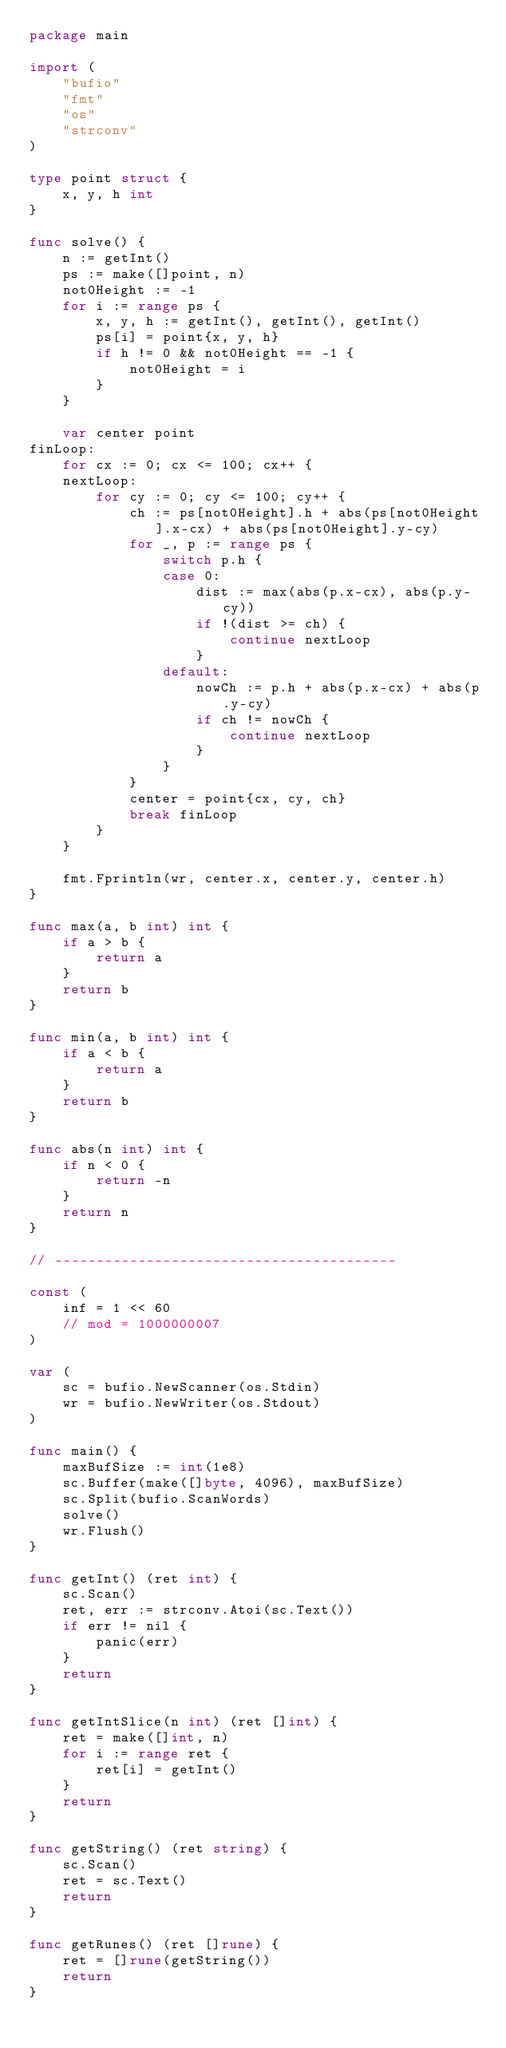Convert code to text. <code><loc_0><loc_0><loc_500><loc_500><_Go_>package main

import (
	"bufio"
	"fmt"
	"os"
	"strconv"
)

type point struct {
	x, y, h int
}

func solve() {
	n := getInt()
	ps := make([]point, n)
	not0Height := -1
	for i := range ps {
		x, y, h := getInt(), getInt(), getInt()
		ps[i] = point{x, y, h}
		if h != 0 && not0Height == -1 {
			not0Height = i
		}
	}

	var center point
finLoop:
	for cx := 0; cx <= 100; cx++ {
	nextLoop:
		for cy := 0; cy <= 100; cy++ {
			ch := ps[not0Height].h + abs(ps[not0Height].x-cx) + abs(ps[not0Height].y-cy)
			for _, p := range ps {
				switch p.h {
				case 0:
					dist := max(abs(p.x-cx), abs(p.y-cy))
					if !(dist >= ch) {
						continue nextLoop
					}
				default:
					nowCh := p.h + abs(p.x-cx) + abs(p.y-cy)
					if ch != nowCh {
						continue nextLoop
					}
				}
			}
			center = point{cx, cy, ch}
			break finLoop
		}
	}

	fmt.Fprintln(wr, center.x, center.y, center.h)
}

func max(a, b int) int {
	if a > b {
		return a
	}
	return b
}

func min(a, b int) int {
	if a < b {
		return a
	}
	return b
}

func abs(n int) int {
	if n < 0 {
		return -n
	}
	return n
}

// -----------------------------------------

const (
	inf = 1 << 60
	// mod = 1000000007
)

var (
	sc = bufio.NewScanner(os.Stdin)
	wr = bufio.NewWriter(os.Stdout)
)

func main() {
	maxBufSize := int(1e8)
	sc.Buffer(make([]byte, 4096), maxBufSize)
	sc.Split(bufio.ScanWords)
	solve()
	wr.Flush()
}

func getInt() (ret int) {
	sc.Scan()
	ret, err := strconv.Atoi(sc.Text())
	if err != nil {
		panic(err)
	}
	return
}

func getIntSlice(n int) (ret []int) {
	ret = make([]int, n)
	for i := range ret {
		ret[i] = getInt()
	}
	return
}

func getString() (ret string) {
	sc.Scan()
	ret = sc.Text()
	return
}

func getRunes() (ret []rune) {
	ret = []rune(getString())
	return
}
</code> 